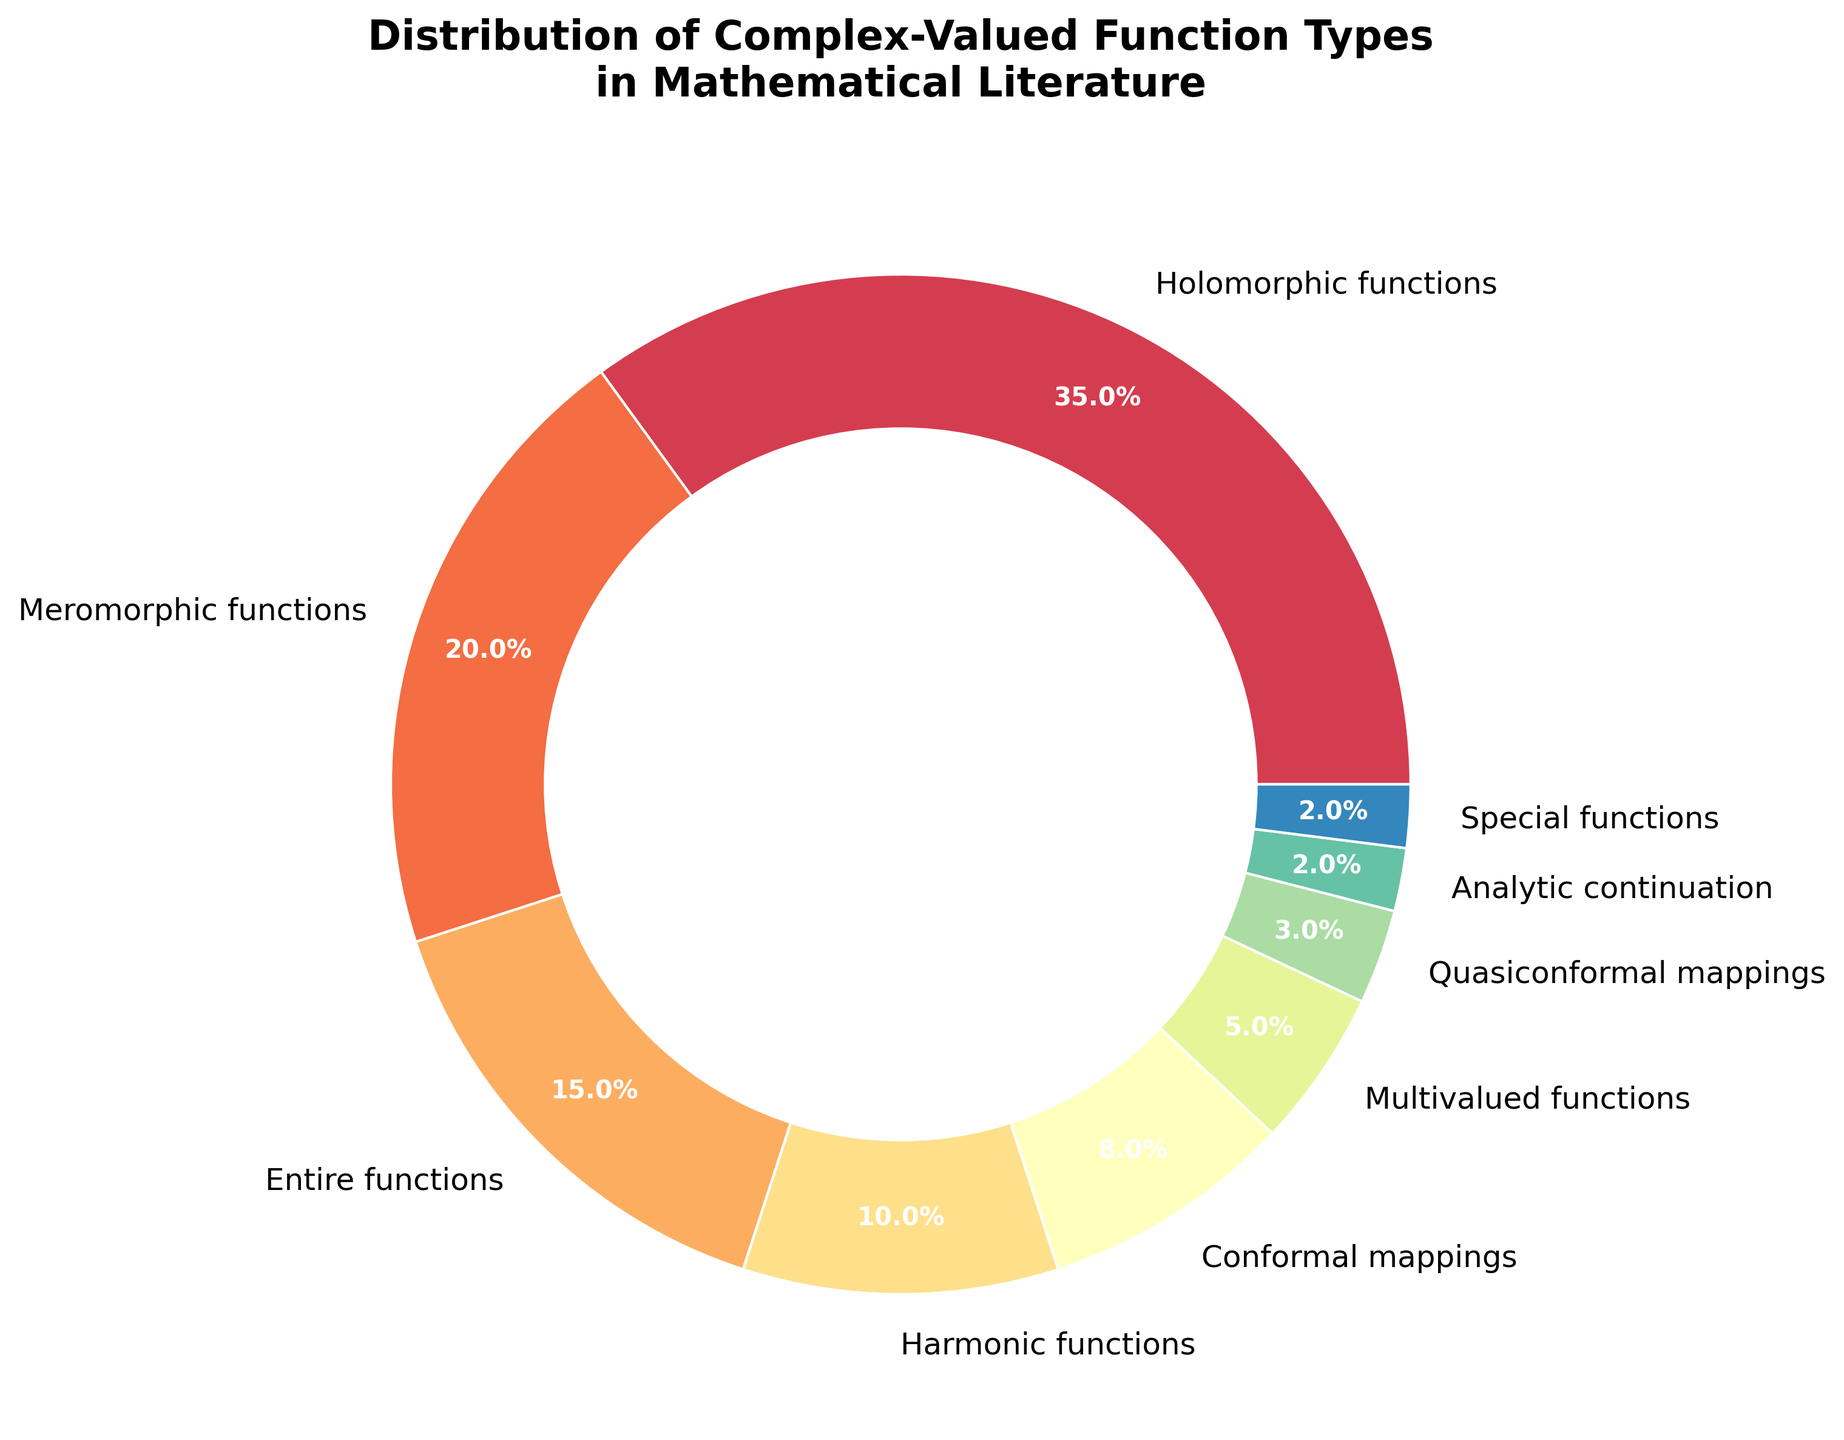What is the largest category in the distribution? The largest category in the distribution is the one with the highest percentage. From the figure, "Holomorphic functions" has the largest slice with 35%.
Answer: Holomorphic functions Which categories have a percentage lower than 10%? To identify the categories with a percentage lower than 10%, look at the slices representing less than 10% each. The categories are "Conformal mappings" (8%), "Multivalued functions" (5%), "Quasiconformal mappings" (3%), "Analytic continuation" (2%), and "Special functions" (2%).
Answer: Conformal mappings, Multivalued functions, Quasiconformal mappings, Analytic continuation, Special functions What is the sum of the percentages of "Holomorphic functions" and "Meromorphic functions"? The percentage for "Holomorphic functions" is 35%, and for "Meromorphic functions" it is 20%. Adding them together gives 35% + 20% = 55%.
Answer: 55% Which categories have equal percentages? From the figure, "Analytic continuation" and "Special functions" both have a percentage of 2%.
Answer: Analytic continuation, Special functions How much more common are "Entire functions" compared to "Conformal mappings"? To find how much more common "Entire functions" are, compare their percentages. "Entire functions" have 15%, and "Conformal mappings" have 8%. The difference is 15% - 8% = 7%.
Answer: 7% What fraction of the distribution is represented by "Multivalued functions"? "Multivalued functions" take up 5% of the distribution. As a fraction of 100%, this is 5/100 = 1/20.
Answer: 1/20 Which category has the smallest slice in the pie chart? The smallest slice corresponds to the category with the lowest percentage. "Analytic continuation" and "Special functions" both share the smallest slice with 2% each.
Answer: Analytic continuation, Special functions Rank the categories in descending order of their percentage. The categories ranked from highest to lowest percentage are: "Holomorphic functions" (35%), "Meromorphic functions" (20%), "Entire functions" (15%), "Harmonic functions" (10%), "Conformal mappings" (8%), "Multivalued functions" (5%), "Quasiconformal mappings" (3%), "Analytic continuation" (2%), and "Special functions" (2%).
Answer: Holomorphic functions, Meromorphic functions, Entire functions, Harmonic functions, Conformal mappings, Multivalued functions, Quasiconformal mappings, Analytic continuation, Special functions If the category "Harmonic functions" represented three times its current percentage, what would its new percentage be? The current percentage of "Harmonic functions" is 10%. If it were three times this value, the new percentage would be 10% * 3 = 30%.
Answer: 30% What is the difference in percentage between "Harmonic functions" and "Entire functions"? The percentage for "Harmonic functions" is 10% and for "Entire functions" is 15%. The difference is 15% - 10% = 5%.
Answer: 5% 